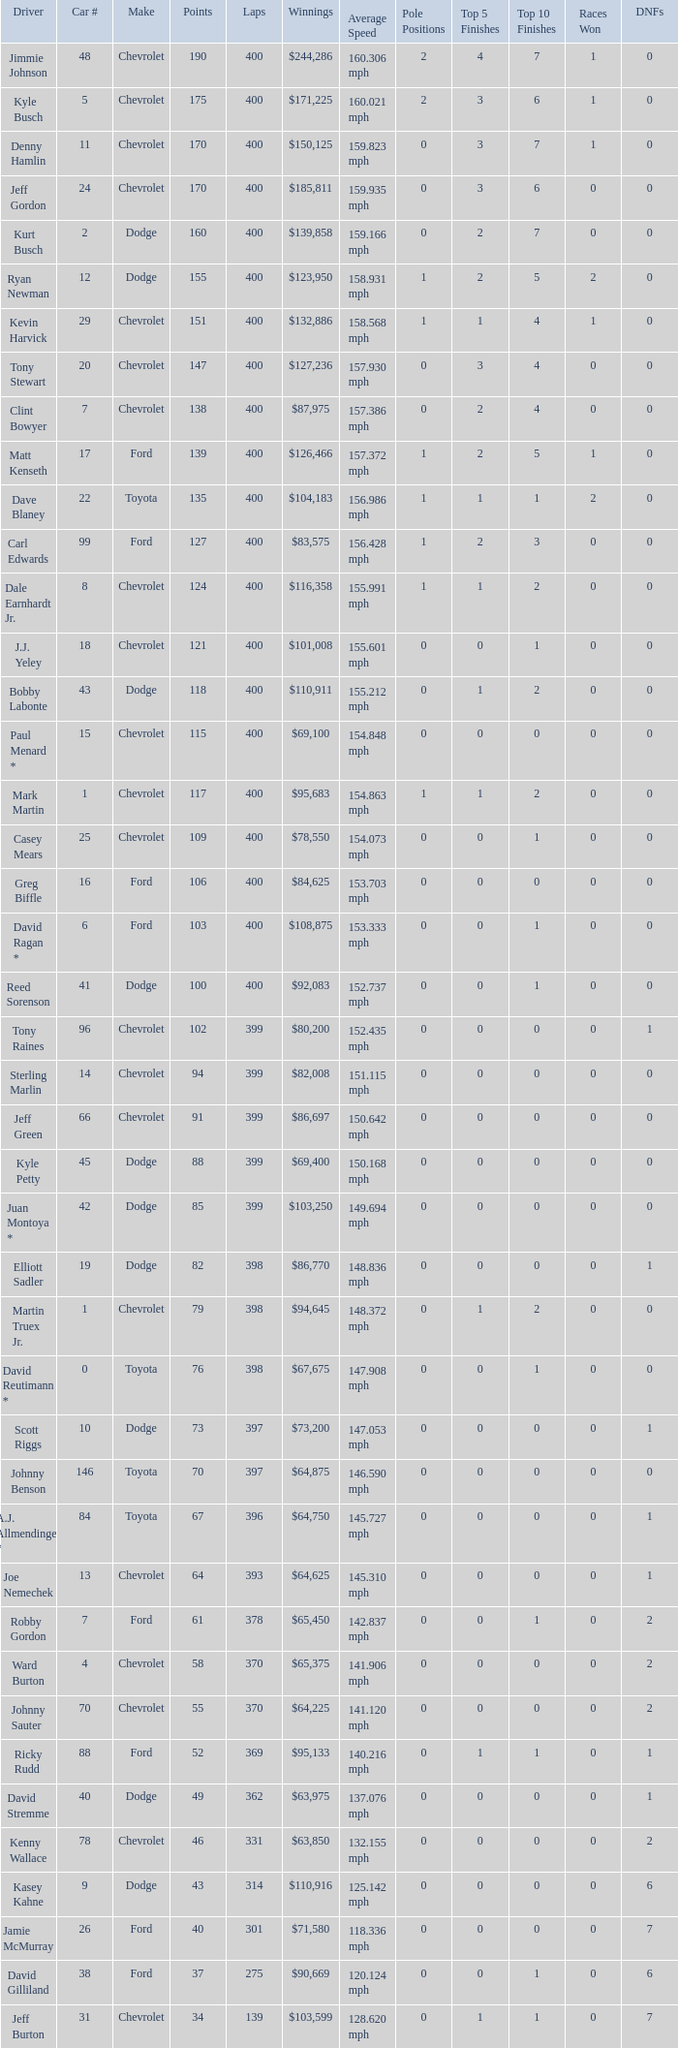What is the car number that has less than 369 laps for a Dodge with more than 49 points? None. 